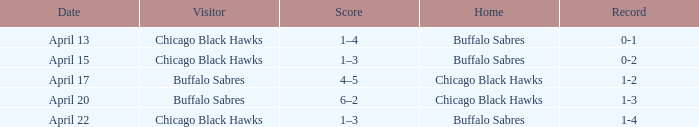Which Score has a Record of 0-1? 1–4. 